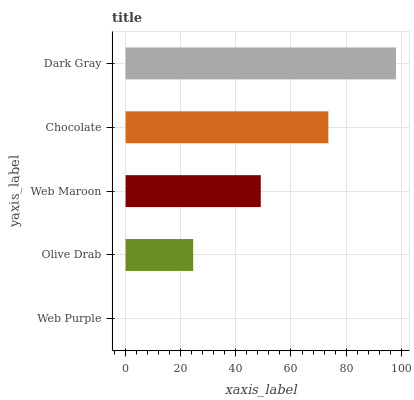Is Web Purple the minimum?
Answer yes or no. Yes. Is Dark Gray the maximum?
Answer yes or no. Yes. Is Olive Drab the minimum?
Answer yes or no. No. Is Olive Drab the maximum?
Answer yes or no. No. Is Olive Drab greater than Web Purple?
Answer yes or no. Yes. Is Web Purple less than Olive Drab?
Answer yes or no. Yes. Is Web Purple greater than Olive Drab?
Answer yes or no. No. Is Olive Drab less than Web Purple?
Answer yes or no. No. Is Web Maroon the high median?
Answer yes or no. Yes. Is Web Maroon the low median?
Answer yes or no. Yes. Is Dark Gray the high median?
Answer yes or no. No. Is Chocolate the low median?
Answer yes or no. No. 